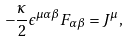Convert formula to latex. <formula><loc_0><loc_0><loc_500><loc_500>- \frac { \kappa } { 2 } \epsilon ^ { \mu \alpha \beta } F _ { \alpha \beta } = J ^ { \mu } ,</formula> 